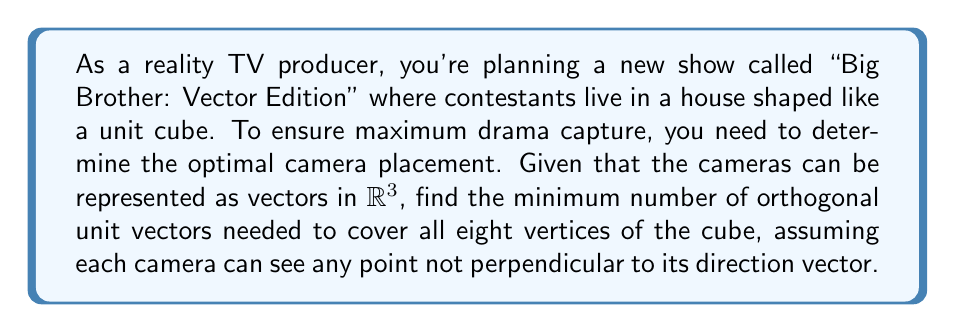Teach me how to tackle this problem. Let's approach this step-by-step:

1) First, we need to understand what it means for a camera to "see" a vertex. A camera represented by a unit vector $\mathbf{v}$ can see a vertex at position $\mathbf{p}$ if their dot product is non-zero: $\mathbf{v} \cdot \mathbf{p} \neq 0$.

2) The vertices of a unit cube centered at the origin can be represented as:
   $(\pm\frac{1}{2}, \pm\frac{1}{2}, \pm\frac{1}{2})$

3) We're looking for orthogonal unit vectors, which means we're effectively searching for an orthonormal basis that can "see" all vertices.

4) Let's consider the standard basis vectors:
   $\mathbf{e}_1 = (1,0,0)$, $\mathbf{e}_2 = (0,1,0)$, $\mathbf{e}_3 = (0,0,1)$

5) For any vertex $\mathbf{p} = (x,y,z)$:
   $\mathbf{e}_1 \cdot \mathbf{p} = x$
   $\mathbf{e}_2 \cdot \mathbf{p} = y$
   $\mathbf{e}_3 \cdot \mathbf{p} = z$

6) Since each coordinate of a vertex is $\pm\frac{1}{2}$, at least one of these dot products will always be non-zero for any vertex.

7) Therefore, these three orthogonal unit vectors are sufficient to "see" all vertices.

8) We can prove that two vectors are not enough:
   - Any two orthogonal vectors define a plane.
   - There will always be a line perpendicular to this plane.
   - The cube has parallel edges, so at least one edge will be parallel to this line.
   - The vertices on this edge will not be "seen" by either vector.

Thus, the minimum number of orthogonal unit vectors needed is 3.
Answer: The minimum number of orthogonal unit vectors needed to cover all eight vertices of the cube is 3. 